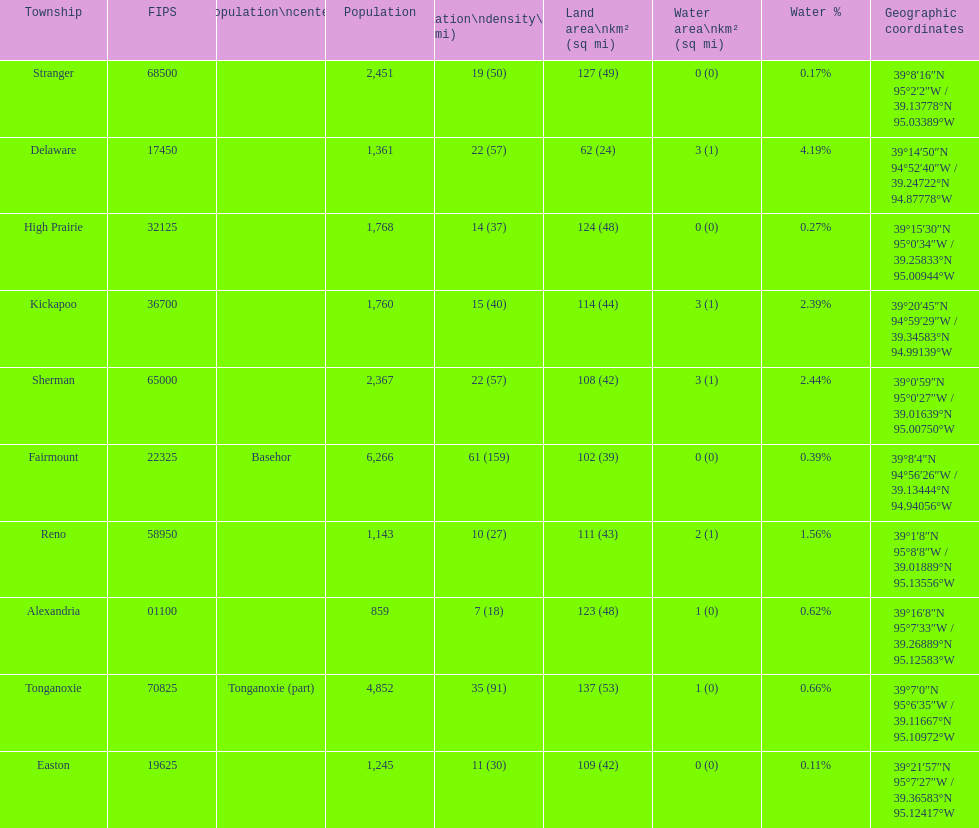How many townships have populations over 2,000? 4. 